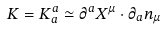Convert formula to latex. <formula><loc_0><loc_0><loc_500><loc_500>K = K ^ { a } _ { a } \simeq \partial ^ { a } X ^ { \mu } \cdot \partial _ { a } n _ { \mu }</formula> 